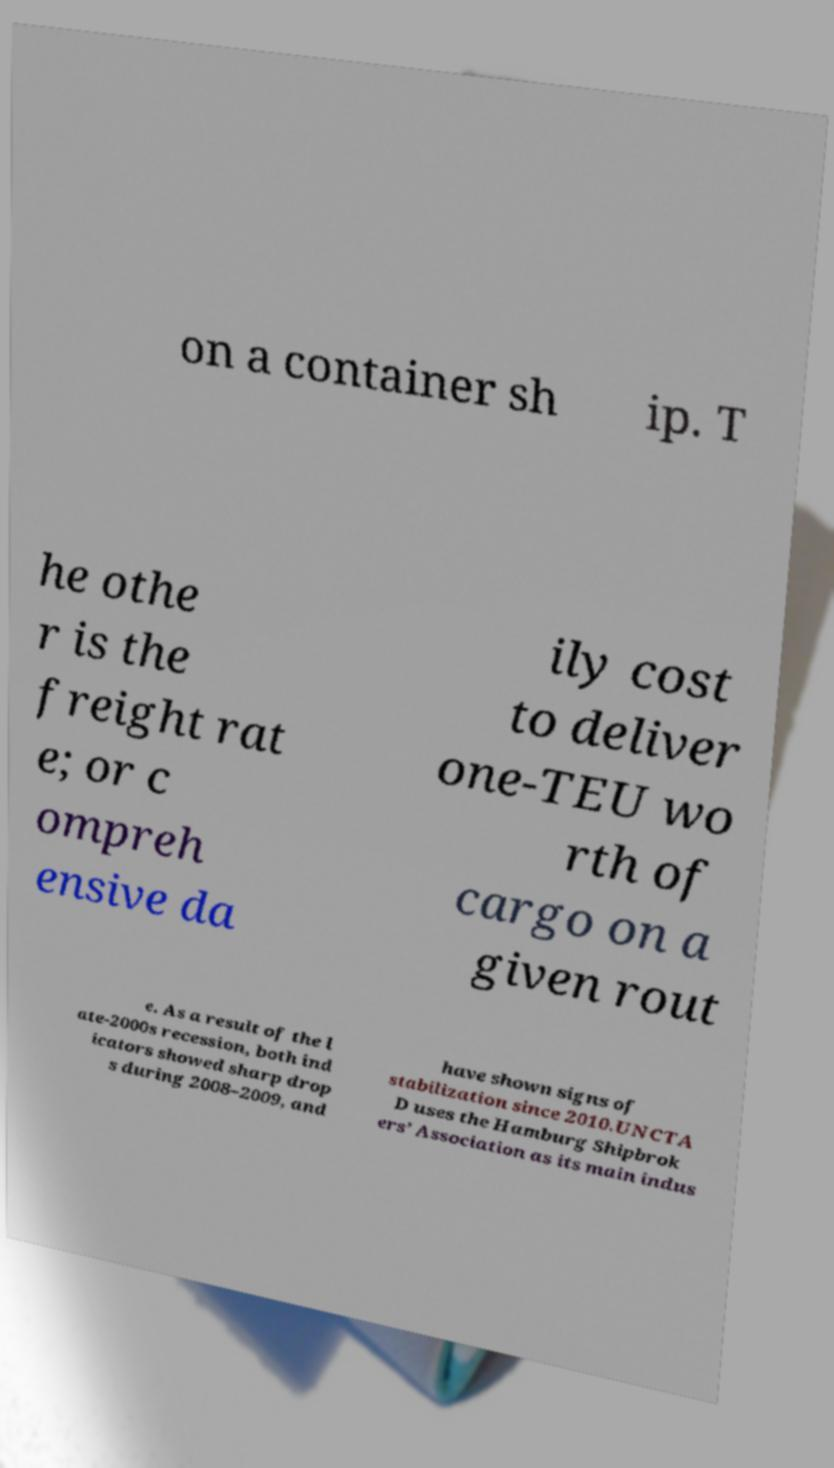I need the written content from this picture converted into text. Can you do that? on a container sh ip. T he othe r is the freight rat e; or c ompreh ensive da ily cost to deliver one-TEU wo rth of cargo on a given rout e. As a result of the l ate-2000s recession, both ind icators showed sharp drop s during 2008–2009, and have shown signs of stabilization since 2010.UNCTA D uses the Hamburg Shipbrok ers’ Association as its main indus 